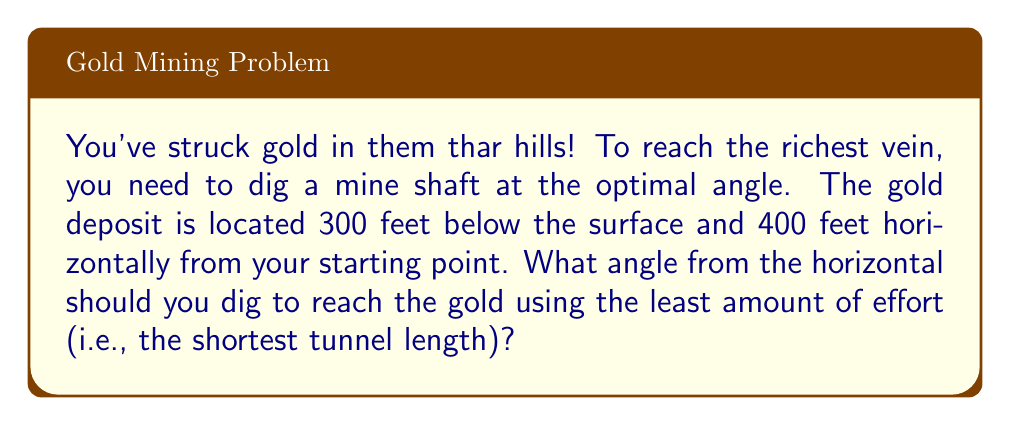Teach me how to tackle this problem. Let's approach this step-by-step, partner:

1) First, we need to visualize the problem. We have a right triangle where:
   - The vertical depth is 300 feet
   - The horizontal distance is 400 feet
   - The hypotenuse is the tunnel we're digging

2) We're looking for the angle that minimizes the length of the tunnel. This is the angle of elevation from the horizontal to the hypotenuse.

3) In a right triangle, we can use the arctangent function to find this angle. The arctangent of the opposite side divided by the adjacent side gives us the angle we're looking for.

4) Let's call our angle θ. We can set up the equation:

   $$\tan(\theta) = \frac{\text{opposite}}{\text{adjacent}} = \frac{300}{400}$$

5) To solve for θ, we take the arctangent (inverse tangent) of both sides:

   $$\theta = \arctan(\frac{300}{400})$$

6) Using a calculator or computer, we can evaluate this:

   $$\theta \approx 36.87°$$

7) To verify this is the optimal angle, we can calculate the length of the tunnel using the Pythagorean theorem:

   $$\text{tunnel length} = \sqrt{300^2 + 400^2} = 500 \text{ feet}$$

   This is indeed the shortest possible path between the two points.
Answer: $36.87°$ 